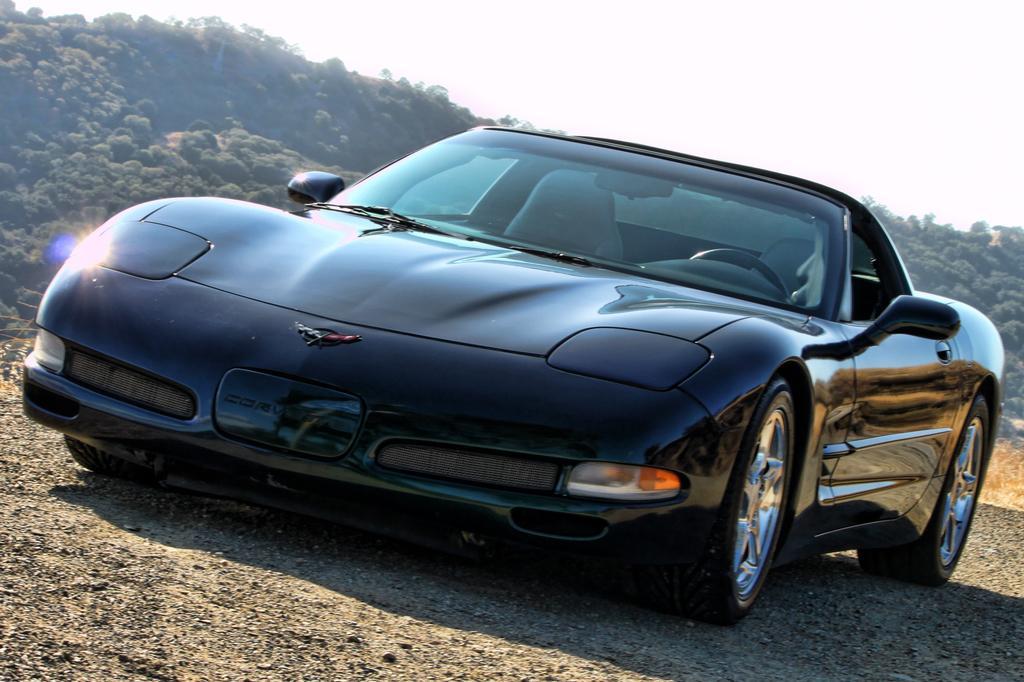Can you describe this image briefly? In this image we can see a car. In the background there are hills, trees and sky. 